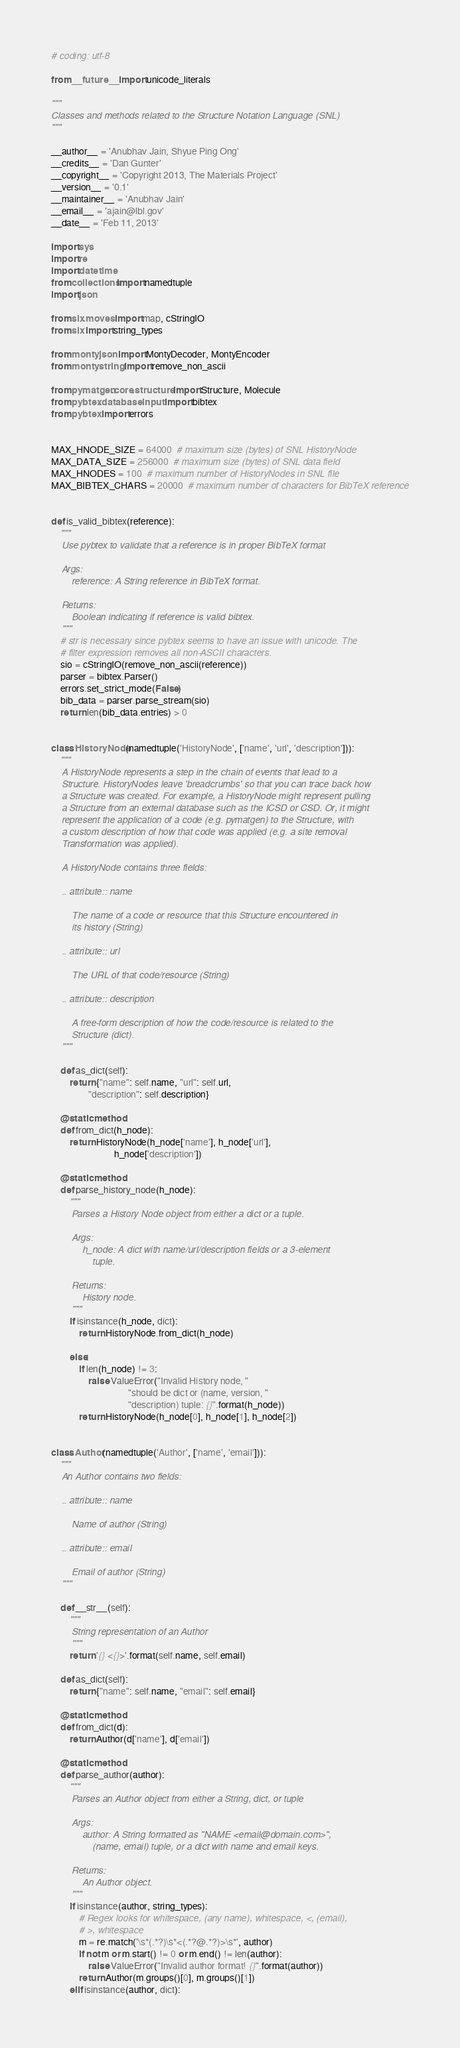Convert code to text. <code><loc_0><loc_0><loc_500><loc_500><_Python_># coding: utf-8

from __future__ import unicode_literals

"""
Classes and methods related to the Structure Notation Language (SNL)
"""

__author__ = 'Anubhav Jain, Shyue Ping Ong'
__credits__ = 'Dan Gunter'
__copyright__ = 'Copyright 2013, The Materials Project'
__version__ = '0.1'
__maintainer__ = 'Anubhav Jain'
__email__ = 'ajain@lbl.gov'
__date__ = 'Feb 11, 2013'

import sys
import re
import datetime
from collections import namedtuple
import json

from six.moves import map, cStringIO
from six import string_types

from monty.json import MontyDecoder, MontyEncoder
from monty.string import remove_non_ascii

from pymatgen.core.structure import Structure, Molecule
from pybtex.database.input import bibtex
from pybtex import errors


MAX_HNODE_SIZE = 64000  # maximum size (bytes) of SNL HistoryNode
MAX_DATA_SIZE = 256000  # maximum size (bytes) of SNL data field
MAX_HNODES = 100  # maximum number of HistoryNodes in SNL file
MAX_BIBTEX_CHARS = 20000  # maximum number of characters for BibTeX reference


def is_valid_bibtex(reference):
    """
    Use pybtex to validate that a reference is in proper BibTeX format

    Args:
        reference: A String reference in BibTeX format.

    Returns:
        Boolean indicating if reference is valid bibtex.
    """
    # str is necessary since pybtex seems to have an issue with unicode. The
    # filter expression removes all non-ASCII characters.
    sio = cStringIO(remove_non_ascii(reference))
    parser = bibtex.Parser()
    errors.set_strict_mode(False)
    bib_data = parser.parse_stream(sio)
    return len(bib_data.entries) > 0


class HistoryNode(namedtuple('HistoryNode', ['name', 'url', 'description'])):
    """
    A HistoryNode represents a step in the chain of events that lead to a
    Structure. HistoryNodes leave 'breadcrumbs' so that you can trace back how
    a Structure was created. For example, a HistoryNode might represent pulling
    a Structure from an external database such as the ICSD or CSD. Or, it might
    represent the application of a code (e.g. pymatgen) to the Structure, with
    a custom description of how that code was applied (e.g. a site removal
    Transformation was applied).

    A HistoryNode contains three fields:

    .. attribute:: name

        The name of a code or resource that this Structure encountered in
        its history (String)

    .. attribute:: url

        The URL of that code/resource (String)

    .. attribute:: description

        A free-form description of how the code/resource is related to the
        Structure (dict).
    """

    def as_dict(self):
        return {"name": self.name, "url": self.url,
                "description": self.description}

    @staticmethod
    def from_dict(h_node):
        return HistoryNode(h_node['name'], h_node['url'],
                           h_node['description'])

    @staticmethod
    def parse_history_node(h_node):
        """
        Parses a History Node object from either a dict or a tuple.

        Args:
            h_node: A dict with name/url/description fields or a 3-element
                tuple.

        Returns:
            History node.
        """
        if isinstance(h_node, dict):
            return HistoryNode.from_dict(h_node)

        else:
            if len(h_node) != 3:
                raise ValueError("Invalid History node, "
                                 "should be dict or (name, version, "
                                 "description) tuple: {}".format(h_node))
            return HistoryNode(h_node[0], h_node[1], h_node[2])


class Author(namedtuple('Author', ['name', 'email'])):
    """
    An Author contains two fields:

    .. attribute:: name

        Name of author (String)

    .. attribute:: email

        Email of author (String)
    """

    def __str__(self):
        """
        String representation of an Author
        """
        return '{} <{}>'.format(self.name, self.email)

    def as_dict(self):
        return {"name": self.name, "email": self.email}

    @staticmethod
    def from_dict(d):
        return Author(d['name'], d['email'])

    @staticmethod
    def parse_author(author):
        """
        Parses an Author object from either a String, dict, or tuple

        Args:
            author: A String formatted as "NAME <email@domain.com>",
                (name, email) tuple, or a dict with name and email keys.

        Returns:
            An Author object.
        """
        if isinstance(author, string_types):
            # Regex looks for whitespace, (any name), whitespace, <, (email),
            # >, whitespace
            m = re.match('\s*(.*?)\s*<(.*?@.*?)>\s*', author)
            if not m or m.start() != 0 or m.end() != len(author):
                raise ValueError("Invalid author format! {}".format(author))
            return Author(m.groups()[0], m.groups()[1])
        elif isinstance(author, dict):</code> 